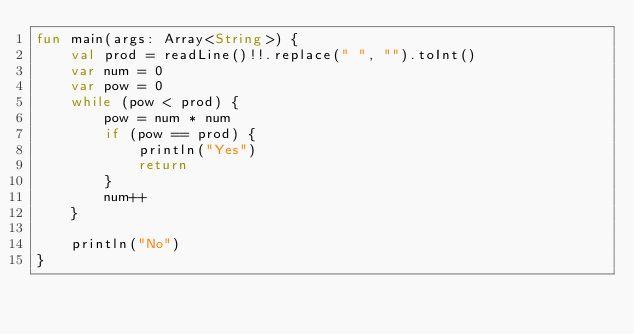Convert code to text. <code><loc_0><loc_0><loc_500><loc_500><_Kotlin_>fun main(args: Array<String>) {
    val prod = readLine()!!.replace(" ", "").toInt()
    var num = 0
    var pow = 0
    while (pow < prod) {
        pow = num * num
        if (pow == prod) {
            println("Yes")
            return
        }
        num++
    }

    println("No")
}</code> 